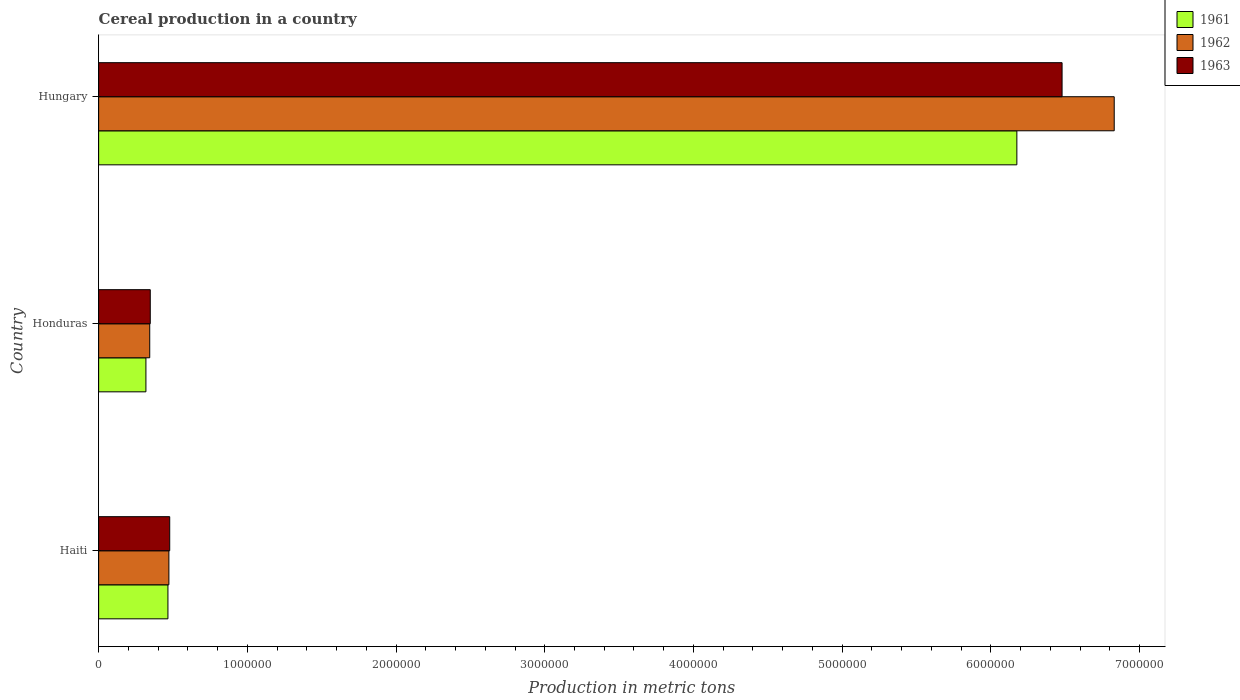Are the number of bars per tick equal to the number of legend labels?
Keep it short and to the point. Yes. Are the number of bars on each tick of the Y-axis equal?
Give a very brief answer. Yes. How many bars are there on the 2nd tick from the top?
Offer a very short reply. 3. What is the label of the 1st group of bars from the top?
Ensure brevity in your answer.  Hungary. What is the total cereal production in 1963 in Honduras?
Give a very brief answer. 3.47e+05. Across all countries, what is the maximum total cereal production in 1962?
Your response must be concise. 6.83e+06. Across all countries, what is the minimum total cereal production in 1963?
Ensure brevity in your answer.  3.47e+05. In which country was the total cereal production in 1962 maximum?
Make the answer very short. Hungary. In which country was the total cereal production in 1963 minimum?
Provide a succinct answer. Honduras. What is the total total cereal production in 1962 in the graph?
Offer a very short reply. 7.65e+06. What is the difference between the total cereal production in 1963 in Haiti and that in Honduras?
Provide a succinct answer. 1.31e+05. What is the difference between the total cereal production in 1963 in Honduras and the total cereal production in 1962 in Haiti?
Your response must be concise. -1.25e+05. What is the average total cereal production in 1962 per country?
Make the answer very short. 2.55e+06. What is the difference between the total cereal production in 1961 and total cereal production in 1963 in Hungary?
Ensure brevity in your answer.  -3.04e+05. In how many countries, is the total cereal production in 1962 greater than 4200000 metric tons?
Make the answer very short. 1. What is the ratio of the total cereal production in 1963 in Haiti to that in Hungary?
Provide a short and direct response. 0.07. Is the total cereal production in 1963 in Haiti less than that in Honduras?
Make the answer very short. No. What is the difference between the highest and the second highest total cereal production in 1962?
Ensure brevity in your answer.  6.36e+06. What is the difference between the highest and the lowest total cereal production in 1961?
Provide a short and direct response. 5.86e+06. In how many countries, is the total cereal production in 1963 greater than the average total cereal production in 1963 taken over all countries?
Keep it short and to the point. 1. Is the sum of the total cereal production in 1962 in Honduras and Hungary greater than the maximum total cereal production in 1961 across all countries?
Your answer should be compact. Yes. Is it the case that in every country, the sum of the total cereal production in 1961 and total cereal production in 1963 is greater than the total cereal production in 1962?
Provide a succinct answer. Yes. Are all the bars in the graph horizontal?
Ensure brevity in your answer.  Yes. Are the values on the major ticks of X-axis written in scientific E-notation?
Ensure brevity in your answer.  No. Does the graph contain grids?
Provide a succinct answer. No. How many legend labels are there?
Give a very brief answer. 3. How are the legend labels stacked?
Your answer should be very brief. Vertical. What is the title of the graph?
Offer a terse response. Cereal production in a country. Does "1992" appear as one of the legend labels in the graph?
Ensure brevity in your answer.  No. What is the label or title of the X-axis?
Offer a terse response. Production in metric tons. What is the label or title of the Y-axis?
Offer a very short reply. Country. What is the Production in metric tons in 1961 in Haiti?
Provide a succinct answer. 4.66e+05. What is the Production in metric tons of 1962 in Haiti?
Give a very brief answer. 4.72e+05. What is the Production in metric tons of 1963 in Haiti?
Give a very brief answer. 4.78e+05. What is the Production in metric tons in 1961 in Honduras?
Ensure brevity in your answer.  3.18e+05. What is the Production in metric tons of 1962 in Honduras?
Give a very brief answer. 3.44e+05. What is the Production in metric tons in 1963 in Honduras?
Offer a terse response. 3.47e+05. What is the Production in metric tons of 1961 in Hungary?
Ensure brevity in your answer.  6.17e+06. What is the Production in metric tons of 1962 in Hungary?
Offer a very short reply. 6.83e+06. What is the Production in metric tons in 1963 in Hungary?
Your answer should be very brief. 6.48e+06. Across all countries, what is the maximum Production in metric tons of 1961?
Make the answer very short. 6.17e+06. Across all countries, what is the maximum Production in metric tons in 1962?
Your response must be concise. 6.83e+06. Across all countries, what is the maximum Production in metric tons of 1963?
Your answer should be very brief. 6.48e+06. Across all countries, what is the minimum Production in metric tons in 1961?
Ensure brevity in your answer.  3.18e+05. Across all countries, what is the minimum Production in metric tons in 1962?
Offer a very short reply. 3.44e+05. Across all countries, what is the minimum Production in metric tons of 1963?
Your answer should be very brief. 3.47e+05. What is the total Production in metric tons in 1961 in the graph?
Offer a terse response. 6.96e+06. What is the total Production in metric tons of 1962 in the graph?
Your response must be concise. 7.65e+06. What is the total Production in metric tons in 1963 in the graph?
Provide a short and direct response. 7.30e+06. What is the difference between the Production in metric tons in 1961 in Haiti and that in Honduras?
Offer a terse response. 1.48e+05. What is the difference between the Production in metric tons of 1962 in Haiti and that in Honduras?
Your answer should be compact. 1.29e+05. What is the difference between the Production in metric tons of 1963 in Haiti and that in Honduras?
Your response must be concise. 1.31e+05. What is the difference between the Production in metric tons in 1961 in Haiti and that in Hungary?
Ensure brevity in your answer.  -5.71e+06. What is the difference between the Production in metric tons in 1962 in Haiti and that in Hungary?
Provide a succinct answer. -6.36e+06. What is the difference between the Production in metric tons in 1963 in Haiti and that in Hungary?
Provide a succinct answer. -6.00e+06. What is the difference between the Production in metric tons in 1961 in Honduras and that in Hungary?
Offer a very short reply. -5.86e+06. What is the difference between the Production in metric tons of 1962 in Honduras and that in Hungary?
Make the answer very short. -6.49e+06. What is the difference between the Production in metric tons in 1963 in Honduras and that in Hungary?
Your answer should be very brief. -6.13e+06. What is the difference between the Production in metric tons of 1961 in Haiti and the Production in metric tons of 1962 in Honduras?
Make the answer very short. 1.22e+05. What is the difference between the Production in metric tons of 1961 in Haiti and the Production in metric tons of 1963 in Honduras?
Your answer should be compact. 1.19e+05. What is the difference between the Production in metric tons in 1962 in Haiti and the Production in metric tons in 1963 in Honduras?
Ensure brevity in your answer.  1.25e+05. What is the difference between the Production in metric tons of 1961 in Haiti and the Production in metric tons of 1962 in Hungary?
Offer a terse response. -6.36e+06. What is the difference between the Production in metric tons of 1961 in Haiti and the Production in metric tons of 1963 in Hungary?
Ensure brevity in your answer.  -6.01e+06. What is the difference between the Production in metric tons of 1962 in Haiti and the Production in metric tons of 1963 in Hungary?
Offer a very short reply. -6.01e+06. What is the difference between the Production in metric tons in 1961 in Honduras and the Production in metric tons in 1962 in Hungary?
Make the answer very short. -6.51e+06. What is the difference between the Production in metric tons in 1961 in Honduras and the Production in metric tons in 1963 in Hungary?
Ensure brevity in your answer.  -6.16e+06. What is the difference between the Production in metric tons of 1962 in Honduras and the Production in metric tons of 1963 in Hungary?
Give a very brief answer. -6.14e+06. What is the average Production in metric tons in 1961 per country?
Provide a succinct answer. 2.32e+06. What is the average Production in metric tons in 1962 per country?
Provide a succinct answer. 2.55e+06. What is the average Production in metric tons in 1963 per country?
Your response must be concise. 2.43e+06. What is the difference between the Production in metric tons in 1961 and Production in metric tons in 1962 in Haiti?
Provide a succinct answer. -6500. What is the difference between the Production in metric tons of 1961 and Production in metric tons of 1963 in Haiti?
Provide a succinct answer. -1.20e+04. What is the difference between the Production in metric tons in 1962 and Production in metric tons in 1963 in Haiti?
Offer a very short reply. -5500. What is the difference between the Production in metric tons in 1961 and Production in metric tons in 1962 in Honduras?
Provide a short and direct response. -2.57e+04. What is the difference between the Production in metric tons in 1961 and Production in metric tons in 1963 in Honduras?
Give a very brief answer. -2.92e+04. What is the difference between the Production in metric tons of 1962 and Production in metric tons of 1963 in Honduras?
Ensure brevity in your answer.  -3541. What is the difference between the Production in metric tons of 1961 and Production in metric tons of 1962 in Hungary?
Offer a terse response. -6.55e+05. What is the difference between the Production in metric tons of 1961 and Production in metric tons of 1963 in Hungary?
Keep it short and to the point. -3.04e+05. What is the difference between the Production in metric tons in 1962 and Production in metric tons in 1963 in Hungary?
Provide a succinct answer. 3.51e+05. What is the ratio of the Production in metric tons of 1961 in Haiti to that in Honduras?
Ensure brevity in your answer.  1.47. What is the ratio of the Production in metric tons in 1962 in Haiti to that in Honduras?
Make the answer very short. 1.37. What is the ratio of the Production in metric tons of 1963 in Haiti to that in Honduras?
Provide a succinct answer. 1.38. What is the ratio of the Production in metric tons in 1961 in Haiti to that in Hungary?
Ensure brevity in your answer.  0.08. What is the ratio of the Production in metric tons in 1962 in Haiti to that in Hungary?
Your answer should be compact. 0.07. What is the ratio of the Production in metric tons of 1963 in Haiti to that in Hungary?
Provide a succinct answer. 0.07. What is the ratio of the Production in metric tons in 1961 in Honduras to that in Hungary?
Your answer should be compact. 0.05. What is the ratio of the Production in metric tons of 1962 in Honduras to that in Hungary?
Ensure brevity in your answer.  0.05. What is the ratio of the Production in metric tons of 1963 in Honduras to that in Hungary?
Your response must be concise. 0.05. What is the difference between the highest and the second highest Production in metric tons of 1961?
Offer a very short reply. 5.71e+06. What is the difference between the highest and the second highest Production in metric tons in 1962?
Your response must be concise. 6.36e+06. What is the difference between the highest and the second highest Production in metric tons of 1963?
Your answer should be very brief. 6.00e+06. What is the difference between the highest and the lowest Production in metric tons of 1961?
Offer a very short reply. 5.86e+06. What is the difference between the highest and the lowest Production in metric tons in 1962?
Keep it short and to the point. 6.49e+06. What is the difference between the highest and the lowest Production in metric tons of 1963?
Offer a terse response. 6.13e+06. 